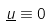Convert formula to latex. <formula><loc_0><loc_0><loc_500><loc_500>\underline { u } \equiv 0</formula> 